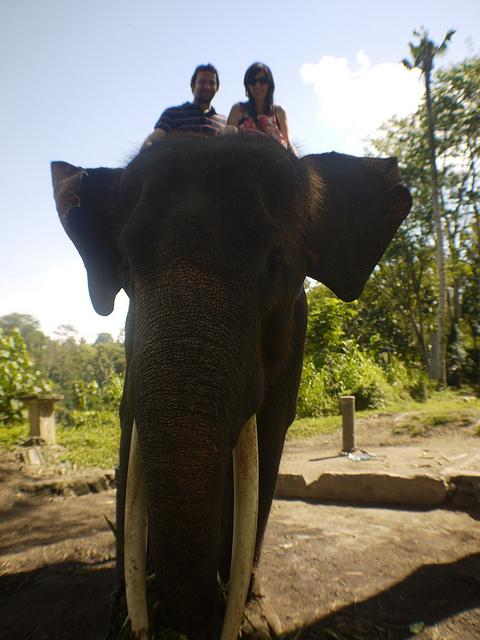Where can you find this animal? africa 